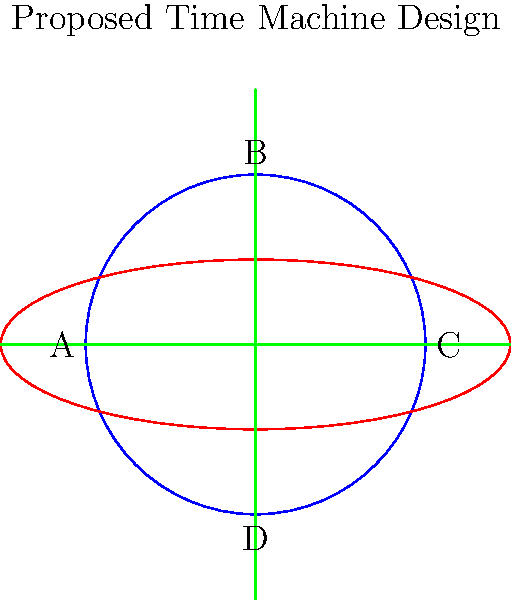In the proposed time machine design shown above, which component is most likely responsible for generating the temporal field necessary for time travel? To answer this question, let's analyze the components of the proposed time machine:

1. The blue circle (B) at the center represents the core of the time machine.
2. The red ellipse (A and C) surrounding the core likely represents an energy containment field.
3. The green perpendicular lines (D) crossing through the center might represent stabilizing elements or power conduits.

In most science fiction depictions of time machines, the core component is usually responsible for generating the temporal field. This is because:

1. The core is centrally located, allowing for even distribution of energy.
2. It's surrounded by other components, suggesting it's the most critical part.
3. In theoretical physics, manipulating spacetime often requires intense energy concentrations, which would likely be generated by a central core.

The elliptical field (A and C) is probably designed to contain and direct the temporal energies generated by the core, while the crossing lines (D) might provide stability or power to the system.

Therefore, the blue circular core (B) is the most likely component responsible for generating the temporal field necessary for time travel.
Answer: Component B (the central blue circle) 